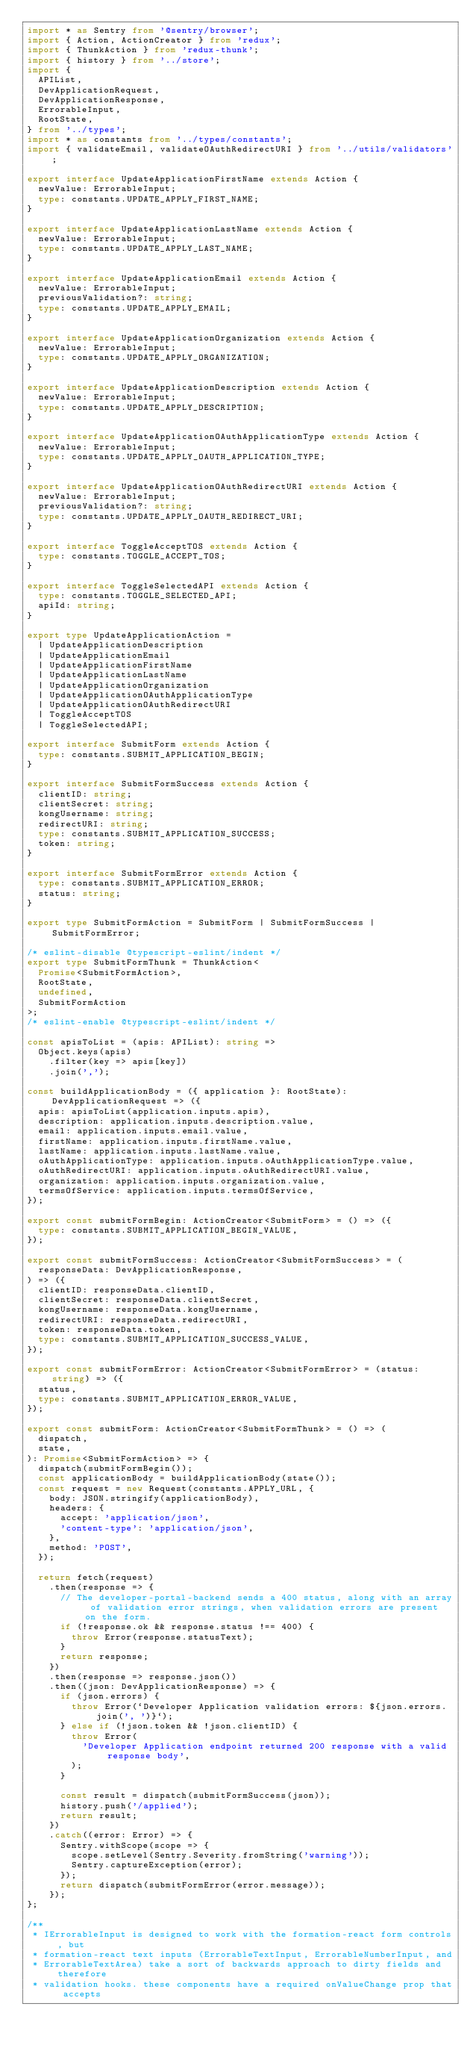Convert code to text. <code><loc_0><loc_0><loc_500><loc_500><_TypeScript_>import * as Sentry from '@sentry/browser';
import { Action, ActionCreator } from 'redux';
import { ThunkAction } from 'redux-thunk';
import { history } from '../store';
import {
  APIList,
  DevApplicationRequest,
  DevApplicationResponse,
  ErrorableInput,
  RootState,
} from '../types';
import * as constants from '../types/constants';
import { validateEmail, validateOAuthRedirectURI } from '../utils/validators';

export interface UpdateApplicationFirstName extends Action {
  newValue: ErrorableInput;
  type: constants.UPDATE_APPLY_FIRST_NAME;
}

export interface UpdateApplicationLastName extends Action {
  newValue: ErrorableInput;
  type: constants.UPDATE_APPLY_LAST_NAME;
}

export interface UpdateApplicationEmail extends Action {
  newValue: ErrorableInput;
  previousValidation?: string;
  type: constants.UPDATE_APPLY_EMAIL;
}

export interface UpdateApplicationOrganization extends Action {
  newValue: ErrorableInput;
  type: constants.UPDATE_APPLY_ORGANIZATION;
}

export interface UpdateApplicationDescription extends Action {
  newValue: ErrorableInput;
  type: constants.UPDATE_APPLY_DESCRIPTION;
}

export interface UpdateApplicationOAuthApplicationType extends Action {
  newValue: ErrorableInput;
  type: constants.UPDATE_APPLY_OAUTH_APPLICATION_TYPE;
}

export interface UpdateApplicationOAuthRedirectURI extends Action {
  newValue: ErrorableInput;
  previousValidation?: string;
  type: constants.UPDATE_APPLY_OAUTH_REDIRECT_URI;
}

export interface ToggleAcceptTOS extends Action {
  type: constants.TOGGLE_ACCEPT_TOS;
}

export interface ToggleSelectedAPI extends Action {
  type: constants.TOGGLE_SELECTED_API;
  apiId: string;
}

export type UpdateApplicationAction =
  | UpdateApplicationDescription
  | UpdateApplicationEmail
  | UpdateApplicationFirstName
  | UpdateApplicationLastName
  | UpdateApplicationOrganization
  | UpdateApplicationOAuthApplicationType
  | UpdateApplicationOAuthRedirectURI
  | ToggleAcceptTOS
  | ToggleSelectedAPI;

export interface SubmitForm extends Action {
  type: constants.SUBMIT_APPLICATION_BEGIN;
}

export interface SubmitFormSuccess extends Action {
  clientID: string;
  clientSecret: string;
  kongUsername: string;
  redirectURI: string;
  type: constants.SUBMIT_APPLICATION_SUCCESS;
  token: string;
}

export interface SubmitFormError extends Action {
  type: constants.SUBMIT_APPLICATION_ERROR;
  status: string;
}

export type SubmitFormAction = SubmitForm | SubmitFormSuccess | SubmitFormError;

/* eslint-disable @typescript-eslint/indent */
export type SubmitFormThunk = ThunkAction<
  Promise<SubmitFormAction>,
  RootState,
  undefined,
  SubmitFormAction
>;
/* eslint-enable @typescript-eslint/indent */

const apisToList = (apis: APIList): string =>
  Object.keys(apis)
    .filter(key => apis[key])
    .join(',');

const buildApplicationBody = ({ application }: RootState): DevApplicationRequest => ({
  apis: apisToList(application.inputs.apis),
  description: application.inputs.description.value,
  email: application.inputs.email.value,
  firstName: application.inputs.firstName.value,
  lastName: application.inputs.lastName.value,
  oAuthApplicationType: application.inputs.oAuthApplicationType.value,
  oAuthRedirectURI: application.inputs.oAuthRedirectURI.value,
  organization: application.inputs.organization.value,
  termsOfService: application.inputs.termsOfService,
});

export const submitFormBegin: ActionCreator<SubmitForm> = () => ({
  type: constants.SUBMIT_APPLICATION_BEGIN_VALUE,
});

export const submitFormSuccess: ActionCreator<SubmitFormSuccess> = (
  responseData: DevApplicationResponse,
) => ({
  clientID: responseData.clientID,
  clientSecret: responseData.clientSecret,
  kongUsername: responseData.kongUsername,
  redirectURI: responseData.redirectURI,
  token: responseData.token,
  type: constants.SUBMIT_APPLICATION_SUCCESS_VALUE,
});

export const submitFormError: ActionCreator<SubmitFormError> = (status: string) => ({
  status,
  type: constants.SUBMIT_APPLICATION_ERROR_VALUE,
});

export const submitForm: ActionCreator<SubmitFormThunk> = () => (
  dispatch,
  state,
): Promise<SubmitFormAction> => {
  dispatch(submitFormBegin());
  const applicationBody = buildApplicationBody(state());
  const request = new Request(constants.APPLY_URL, {
    body: JSON.stringify(applicationBody),
    headers: {
      accept: 'application/json',
      'content-type': 'application/json',
    },
    method: 'POST',
  });

  return fetch(request)
    .then(response => {
      // The developer-portal-backend sends a 400 status, along with an array of validation error strings, when validation errors are present on the form.
      if (!response.ok && response.status !== 400) {
        throw Error(response.statusText);
      }
      return response;
    })
    .then(response => response.json())
    .then((json: DevApplicationResponse) => {
      if (json.errors) {
        throw Error(`Developer Application validation errors: ${json.errors.join(', ')}`);
      } else if (!json.token && !json.clientID) {
        throw Error(
          'Developer Application endpoint returned 200 response with a valid response body',
        );
      }

      const result = dispatch(submitFormSuccess(json));
      history.push('/applied');
      return result;
    })
    .catch((error: Error) => {
      Sentry.withScope(scope => {
        scope.setLevel(Sentry.Severity.fromString('warning'));
        Sentry.captureException(error);
      });
      return dispatch(submitFormError(error.message));
    });
};

/**
 * IErrorableInput is designed to work with the formation-react form controls, but
 * formation-react text inputs (ErrorableTextInput, ErrorableNumberInput, and
 * ErrorableTextArea) take a sort of backwards approach to dirty fields and therefore
 * validation hooks. these components have a required onValueChange prop that accepts</code> 